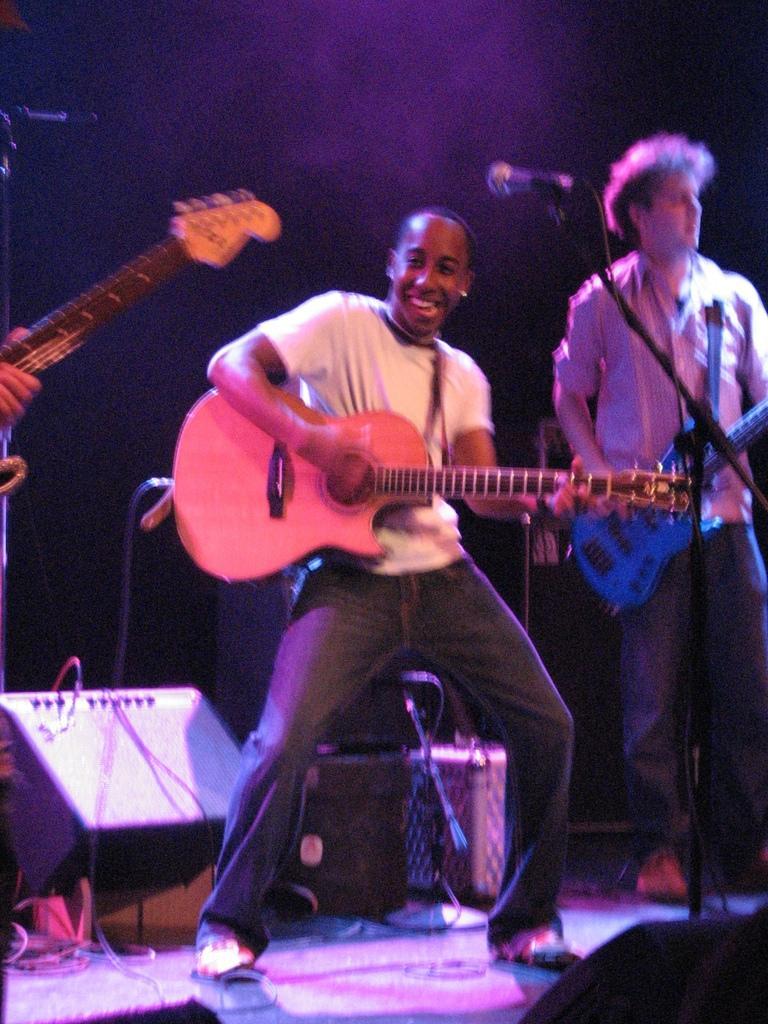Could you give a brief overview of what you see in this image? In this image I see 2 men who are holding the guitar and this guy is smiling and standing in front of a mic. In the background I see few equipment and the speaker. 